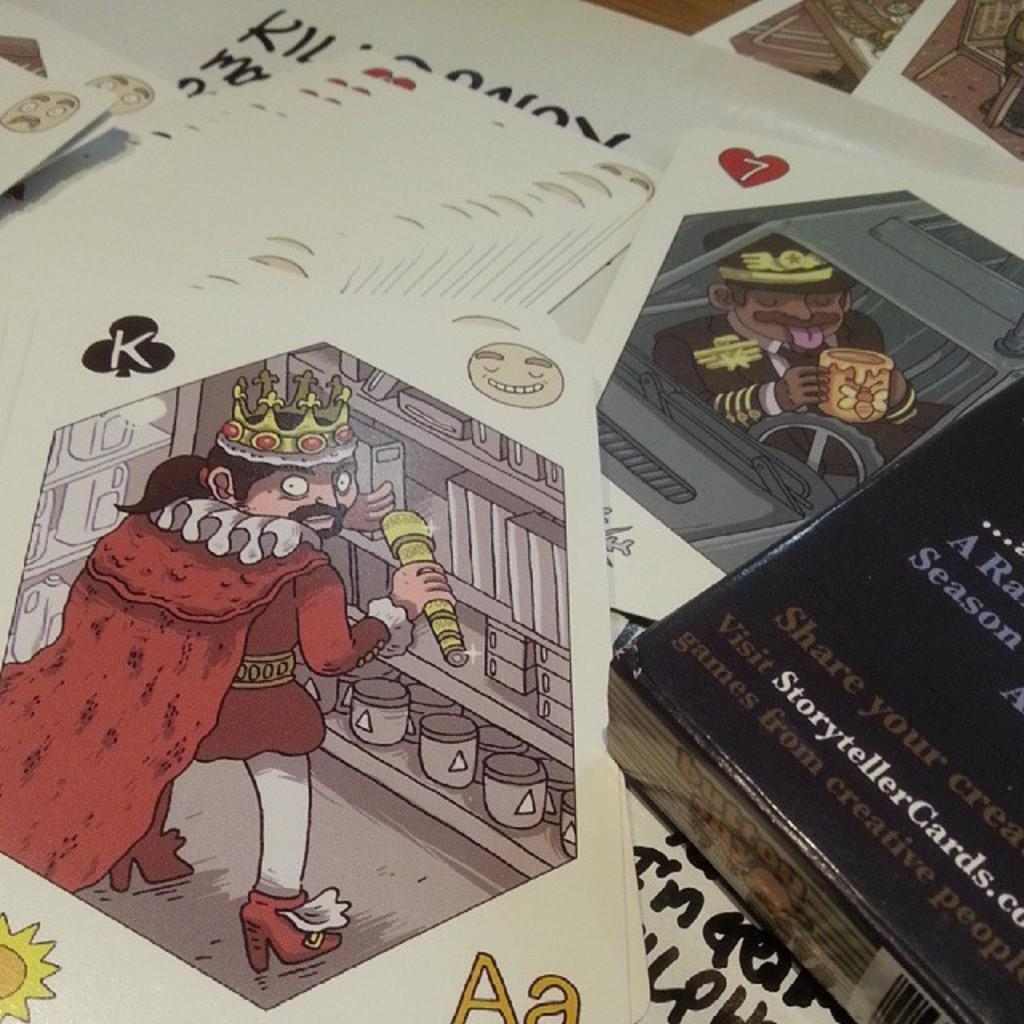<image>
Render a clear and concise summary of the photo. Fortune cards are sitting in a pile next to a black book that says visit storytellercards.com 